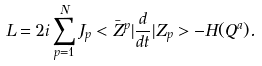Convert formula to latex. <formula><loc_0><loc_0><loc_500><loc_500>L = 2 i \sum _ { p = 1 } ^ { N } J _ { p } < \bar { Z } ^ { p } | \frac { d } { d t } | Z _ { p } > - H ( Q ^ { a } ) .</formula> 